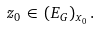<formula> <loc_0><loc_0><loc_500><loc_500>z _ { 0 } \, \in \, ( E _ { G } ) _ { x _ { 0 } } \, .</formula> 